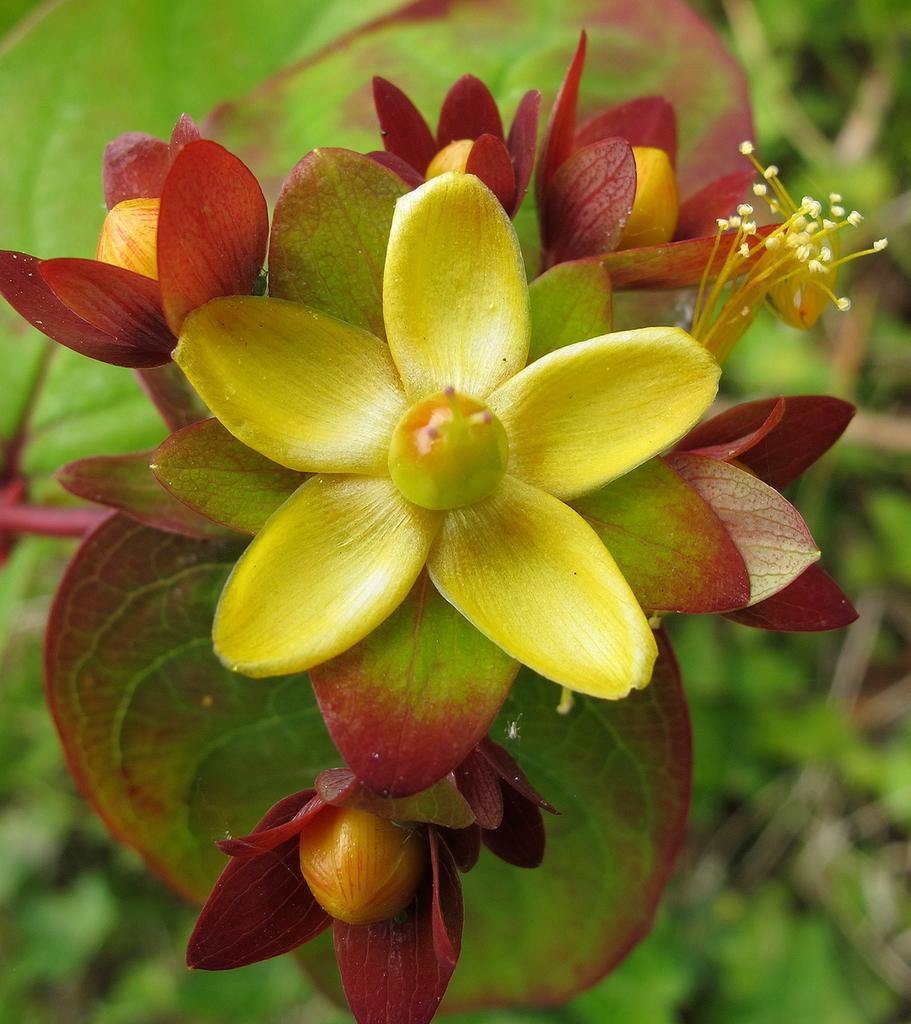What is the main subject of the image? The main subject of the image is flowers. Where are the flowers located in the image? The flowers are in the center of the image. What type of board can be seen in the image? There is no board present in the image; it only features flowers in the center. 